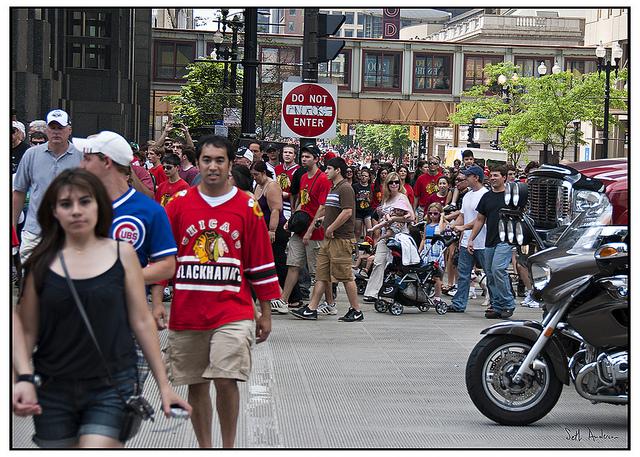What is the big red object?
Quick response, please. Truck. How many baby strollers are there?
Answer briefly. 1. Is there a motorcycle in the picture?
Short answer required. Yes. What sports team does the red t shirt depict?
Be succinct. Blackhawks. 